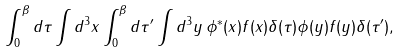Convert formula to latex. <formula><loc_0><loc_0><loc_500><loc_500>\int _ { 0 } ^ { \beta } d \tau \int d ^ { 3 } { x } \int _ { 0 } ^ { \beta } d \tau ^ { \prime } \int d ^ { 3 } { y } \, \phi ^ { * } ( { x } ) f ( { x } ) \delta ( \tau ) \phi ( { y } ) f ( { y } ) \delta ( \tau ^ { \prime } ) ,</formula> 